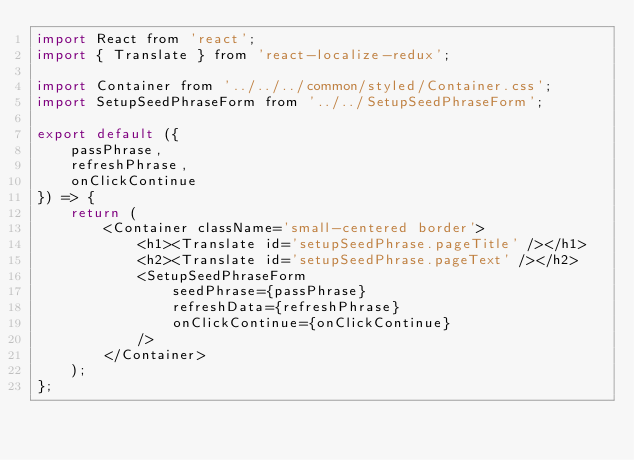Convert code to text. <code><loc_0><loc_0><loc_500><loc_500><_JavaScript_>import React from 'react';
import { Translate } from 'react-localize-redux';

import Container from '../../../common/styled/Container.css';
import SetupSeedPhraseForm from '../../SetupSeedPhraseForm';

export default ({
    passPhrase,
    refreshPhrase,
    onClickContinue
}) => {
    return (
        <Container className='small-centered border'>
            <h1><Translate id='setupSeedPhrase.pageTitle' /></h1>
            <h2><Translate id='setupSeedPhrase.pageText' /></h2>
            <SetupSeedPhraseForm
                seedPhrase={passPhrase}
                refreshData={refreshPhrase}
                onClickContinue={onClickContinue}
            />
        </Container>
    );
};
</code> 